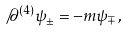<formula> <loc_0><loc_0><loc_500><loc_500>\not \, \partial ^ { ( 4 ) } \psi _ { \pm } = - m \psi _ { \mp } ,</formula> 